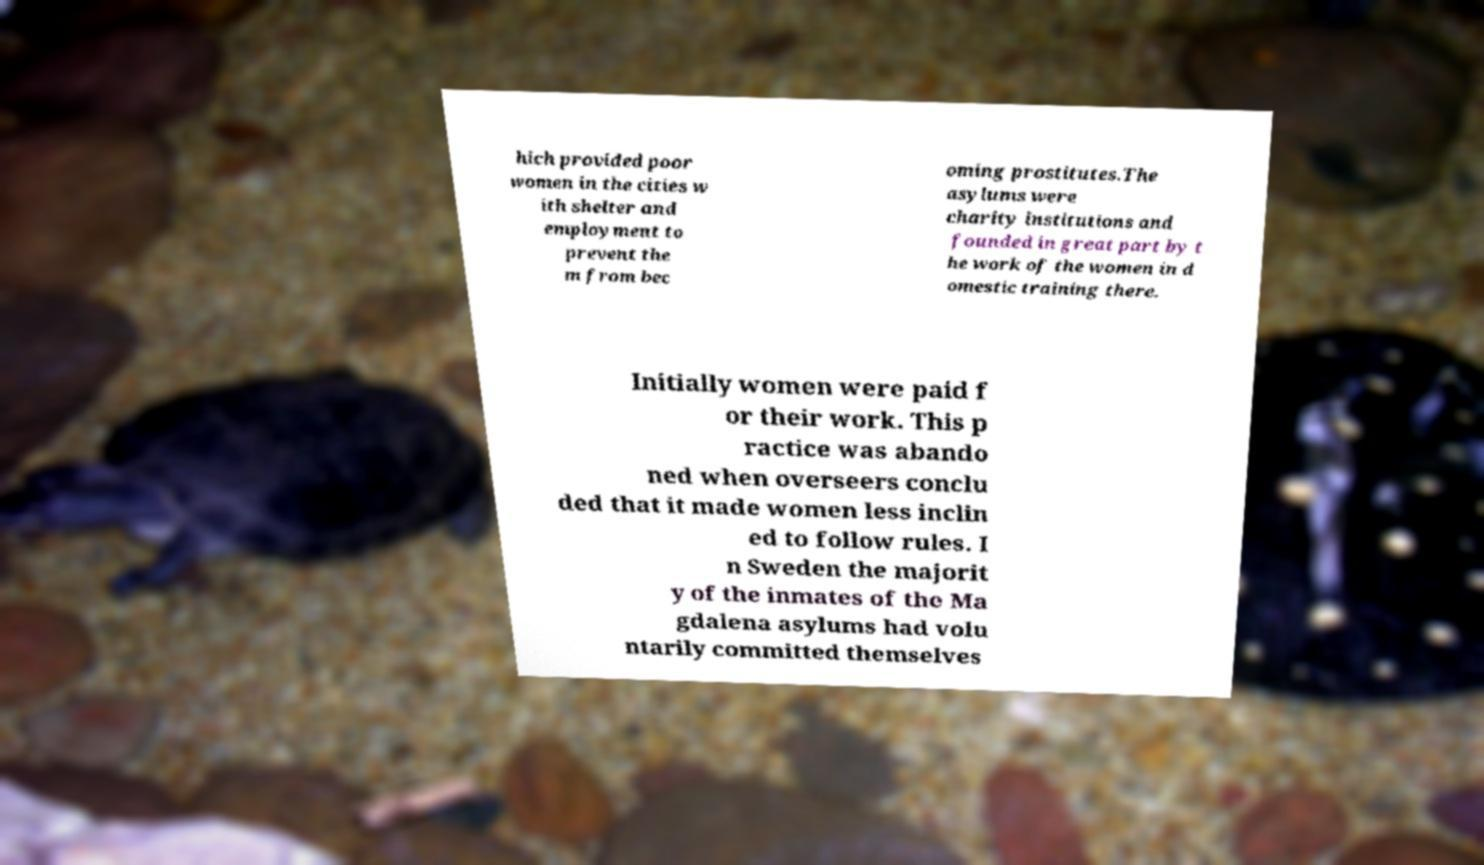Can you accurately transcribe the text from the provided image for me? hich provided poor women in the cities w ith shelter and employment to prevent the m from bec oming prostitutes.The asylums were charity institutions and founded in great part by t he work of the women in d omestic training there. Initially women were paid f or their work. This p ractice was abando ned when overseers conclu ded that it made women less inclin ed to follow rules. I n Sweden the majorit y of the inmates of the Ma gdalena asylums had volu ntarily committed themselves 